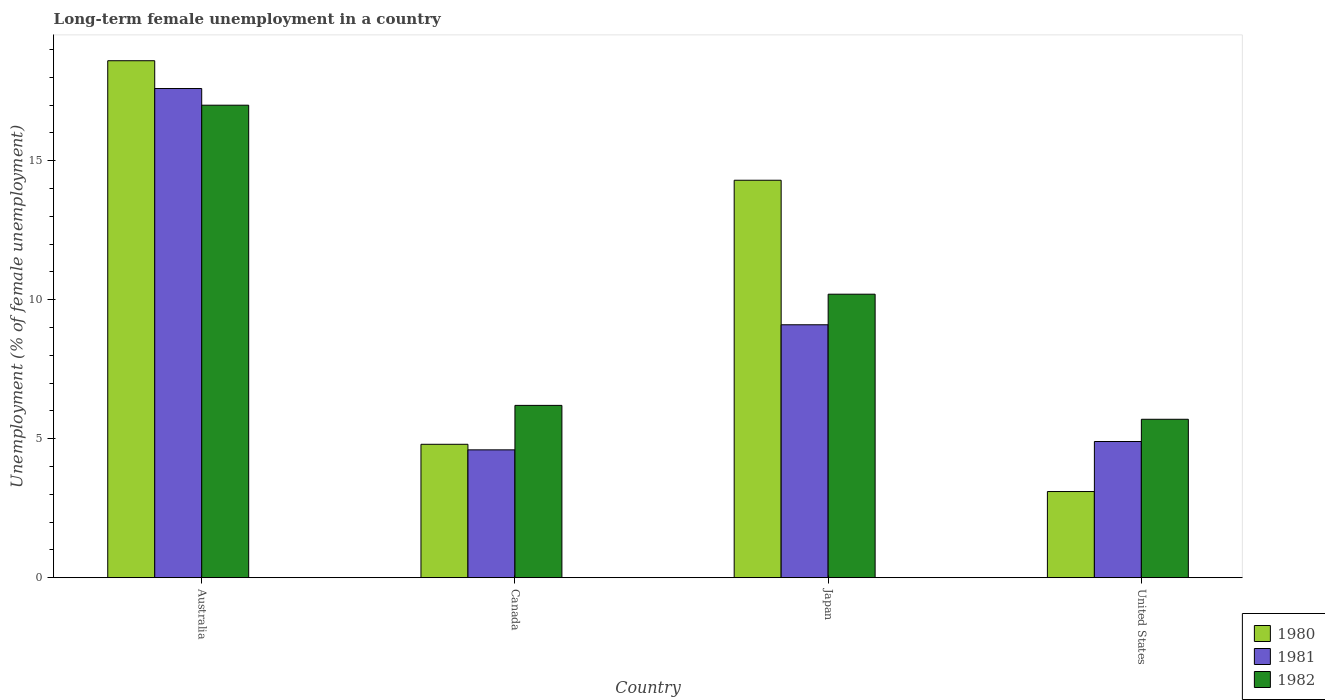Are the number of bars per tick equal to the number of legend labels?
Provide a succinct answer. Yes. How many bars are there on the 3rd tick from the left?
Offer a very short reply. 3. What is the percentage of long-term unemployed female population in 1982 in Canada?
Provide a short and direct response. 6.2. Across all countries, what is the maximum percentage of long-term unemployed female population in 1982?
Your response must be concise. 17. Across all countries, what is the minimum percentage of long-term unemployed female population in 1980?
Your response must be concise. 3.1. In which country was the percentage of long-term unemployed female population in 1982 minimum?
Your answer should be compact. United States. What is the total percentage of long-term unemployed female population in 1982 in the graph?
Your answer should be compact. 39.1. What is the difference between the percentage of long-term unemployed female population in 1982 in Japan and the percentage of long-term unemployed female population in 1981 in Australia?
Provide a short and direct response. -7.4. What is the average percentage of long-term unemployed female population in 1980 per country?
Ensure brevity in your answer.  10.2. What is the difference between the percentage of long-term unemployed female population of/in 1980 and percentage of long-term unemployed female population of/in 1981 in Japan?
Your answer should be compact. 5.2. What is the ratio of the percentage of long-term unemployed female population in 1982 in Australia to that in United States?
Provide a succinct answer. 2.98. Is the difference between the percentage of long-term unemployed female population in 1980 in Canada and United States greater than the difference between the percentage of long-term unemployed female population in 1981 in Canada and United States?
Your answer should be very brief. Yes. What is the difference between the highest and the second highest percentage of long-term unemployed female population in 1982?
Provide a short and direct response. 6.8. What is the difference between the highest and the lowest percentage of long-term unemployed female population in 1980?
Give a very brief answer. 15.5. Is the sum of the percentage of long-term unemployed female population in 1981 in Japan and United States greater than the maximum percentage of long-term unemployed female population in 1982 across all countries?
Your answer should be compact. No. Does the graph contain any zero values?
Your response must be concise. No. Does the graph contain grids?
Your answer should be very brief. No. Where does the legend appear in the graph?
Your answer should be compact. Bottom right. How many legend labels are there?
Offer a very short reply. 3. What is the title of the graph?
Offer a very short reply. Long-term female unemployment in a country. Does "1986" appear as one of the legend labels in the graph?
Keep it short and to the point. No. What is the label or title of the Y-axis?
Your answer should be compact. Unemployment (% of female unemployment). What is the Unemployment (% of female unemployment) in 1980 in Australia?
Give a very brief answer. 18.6. What is the Unemployment (% of female unemployment) of 1981 in Australia?
Your answer should be compact. 17.6. What is the Unemployment (% of female unemployment) of 1980 in Canada?
Provide a short and direct response. 4.8. What is the Unemployment (% of female unemployment) in 1981 in Canada?
Give a very brief answer. 4.6. What is the Unemployment (% of female unemployment) of 1982 in Canada?
Keep it short and to the point. 6.2. What is the Unemployment (% of female unemployment) in 1980 in Japan?
Make the answer very short. 14.3. What is the Unemployment (% of female unemployment) in 1981 in Japan?
Provide a succinct answer. 9.1. What is the Unemployment (% of female unemployment) in 1982 in Japan?
Ensure brevity in your answer.  10.2. What is the Unemployment (% of female unemployment) in 1980 in United States?
Give a very brief answer. 3.1. What is the Unemployment (% of female unemployment) in 1981 in United States?
Provide a succinct answer. 4.9. What is the Unemployment (% of female unemployment) in 1982 in United States?
Offer a terse response. 5.7. Across all countries, what is the maximum Unemployment (% of female unemployment) in 1980?
Make the answer very short. 18.6. Across all countries, what is the maximum Unemployment (% of female unemployment) of 1981?
Offer a very short reply. 17.6. Across all countries, what is the minimum Unemployment (% of female unemployment) of 1980?
Your answer should be compact. 3.1. Across all countries, what is the minimum Unemployment (% of female unemployment) of 1981?
Offer a terse response. 4.6. Across all countries, what is the minimum Unemployment (% of female unemployment) of 1982?
Ensure brevity in your answer.  5.7. What is the total Unemployment (% of female unemployment) in 1980 in the graph?
Make the answer very short. 40.8. What is the total Unemployment (% of female unemployment) in 1981 in the graph?
Provide a succinct answer. 36.2. What is the total Unemployment (% of female unemployment) in 1982 in the graph?
Ensure brevity in your answer.  39.1. What is the difference between the Unemployment (% of female unemployment) in 1980 in Australia and that in Canada?
Your answer should be compact. 13.8. What is the difference between the Unemployment (% of female unemployment) of 1982 in Australia and that in Canada?
Provide a short and direct response. 10.8. What is the difference between the Unemployment (% of female unemployment) in 1980 in Australia and that in Japan?
Provide a short and direct response. 4.3. What is the difference between the Unemployment (% of female unemployment) in 1982 in Australia and that in Japan?
Provide a succinct answer. 6.8. What is the difference between the Unemployment (% of female unemployment) in 1981 in Australia and that in United States?
Keep it short and to the point. 12.7. What is the difference between the Unemployment (% of female unemployment) of 1982 in Australia and that in United States?
Ensure brevity in your answer.  11.3. What is the difference between the Unemployment (% of female unemployment) of 1980 in Canada and that in Japan?
Offer a terse response. -9.5. What is the difference between the Unemployment (% of female unemployment) in 1981 in Canada and that in Japan?
Provide a succinct answer. -4.5. What is the difference between the Unemployment (% of female unemployment) in 1982 in Canada and that in United States?
Make the answer very short. 0.5. What is the difference between the Unemployment (% of female unemployment) of 1980 in Japan and that in United States?
Your answer should be very brief. 11.2. What is the difference between the Unemployment (% of female unemployment) of 1981 in Japan and that in United States?
Offer a terse response. 4.2. What is the difference between the Unemployment (% of female unemployment) of 1982 in Japan and that in United States?
Your response must be concise. 4.5. What is the difference between the Unemployment (% of female unemployment) of 1980 in Australia and the Unemployment (% of female unemployment) of 1982 in Canada?
Ensure brevity in your answer.  12.4. What is the difference between the Unemployment (% of female unemployment) of 1980 in Australia and the Unemployment (% of female unemployment) of 1981 in Japan?
Offer a very short reply. 9.5. What is the difference between the Unemployment (% of female unemployment) of 1980 in Australia and the Unemployment (% of female unemployment) of 1982 in Japan?
Make the answer very short. 8.4. What is the difference between the Unemployment (% of female unemployment) in 1980 in Australia and the Unemployment (% of female unemployment) in 1982 in United States?
Offer a terse response. 12.9. What is the difference between the Unemployment (% of female unemployment) of 1980 in Canada and the Unemployment (% of female unemployment) of 1982 in Japan?
Your answer should be very brief. -5.4. What is the difference between the Unemployment (% of female unemployment) in 1980 in Japan and the Unemployment (% of female unemployment) in 1981 in United States?
Ensure brevity in your answer.  9.4. What is the average Unemployment (% of female unemployment) of 1981 per country?
Keep it short and to the point. 9.05. What is the average Unemployment (% of female unemployment) in 1982 per country?
Your answer should be compact. 9.78. What is the difference between the Unemployment (% of female unemployment) of 1980 and Unemployment (% of female unemployment) of 1981 in Australia?
Offer a terse response. 1. What is the difference between the Unemployment (% of female unemployment) in 1980 and Unemployment (% of female unemployment) in 1982 in Australia?
Offer a terse response. 1.6. What is the difference between the Unemployment (% of female unemployment) of 1981 and Unemployment (% of female unemployment) of 1982 in Australia?
Ensure brevity in your answer.  0.6. What is the difference between the Unemployment (% of female unemployment) in 1980 and Unemployment (% of female unemployment) in 1981 in Japan?
Give a very brief answer. 5.2. What is the difference between the Unemployment (% of female unemployment) in 1980 and Unemployment (% of female unemployment) in 1982 in Japan?
Your answer should be compact. 4.1. What is the difference between the Unemployment (% of female unemployment) of 1981 and Unemployment (% of female unemployment) of 1982 in Japan?
Make the answer very short. -1.1. What is the difference between the Unemployment (% of female unemployment) of 1980 and Unemployment (% of female unemployment) of 1981 in United States?
Your response must be concise. -1.8. What is the difference between the Unemployment (% of female unemployment) of 1980 and Unemployment (% of female unemployment) of 1982 in United States?
Keep it short and to the point. -2.6. What is the difference between the Unemployment (% of female unemployment) in 1981 and Unemployment (% of female unemployment) in 1982 in United States?
Your response must be concise. -0.8. What is the ratio of the Unemployment (% of female unemployment) in 1980 in Australia to that in Canada?
Give a very brief answer. 3.88. What is the ratio of the Unemployment (% of female unemployment) in 1981 in Australia to that in Canada?
Your response must be concise. 3.83. What is the ratio of the Unemployment (% of female unemployment) of 1982 in Australia to that in Canada?
Give a very brief answer. 2.74. What is the ratio of the Unemployment (% of female unemployment) of 1980 in Australia to that in Japan?
Ensure brevity in your answer.  1.3. What is the ratio of the Unemployment (% of female unemployment) of 1981 in Australia to that in Japan?
Provide a succinct answer. 1.93. What is the ratio of the Unemployment (% of female unemployment) of 1981 in Australia to that in United States?
Your answer should be compact. 3.59. What is the ratio of the Unemployment (% of female unemployment) in 1982 in Australia to that in United States?
Your response must be concise. 2.98. What is the ratio of the Unemployment (% of female unemployment) of 1980 in Canada to that in Japan?
Your answer should be compact. 0.34. What is the ratio of the Unemployment (% of female unemployment) of 1981 in Canada to that in Japan?
Offer a very short reply. 0.51. What is the ratio of the Unemployment (% of female unemployment) of 1982 in Canada to that in Japan?
Your answer should be compact. 0.61. What is the ratio of the Unemployment (% of female unemployment) of 1980 in Canada to that in United States?
Provide a succinct answer. 1.55. What is the ratio of the Unemployment (% of female unemployment) of 1981 in Canada to that in United States?
Your response must be concise. 0.94. What is the ratio of the Unemployment (% of female unemployment) in 1982 in Canada to that in United States?
Offer a very short reply. 1.09. What is the ratio of the Unemployment (% of female unemployment) of 1980 in Japan to that in United States?
Give a very brief answer. 4.61. What is the ratio of the Unemployment (% of female unemployment) in 1981 in Japan to that in United States?
Your answer should be compact. 1.86. What is the ratio of the Unemployment (% of female unemployment) in 1982 in Japan to that in United States?
Your answer should be compact. 1.79. What is the difference between the highest and the second highest Unemployment (% of female unemployment) of 1980?
Offer a terse response. 4.3. What is the difference between the highest and the second highest Unemployment (% of female unemployment) of 1982?
Your answer should be very brief. 6.8. What is the difference between the highest and the lowest Unemployment (% of female unemployment) in 1982?
Ensure brevity in your answer.  11.3. 